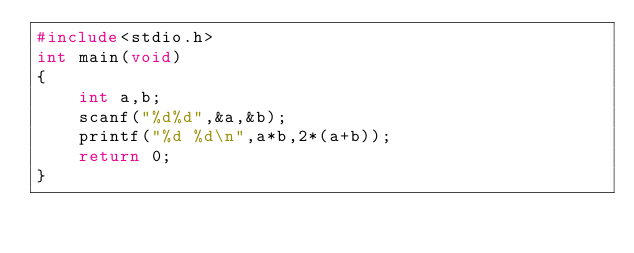Convert code to text. <code><loc_0><loc_0><loc_500><loc_500><_C_>#include<stdio.h>
int main(void)
{
    int a,b;
    scanf("%d%d",&a,&b);
    printf("%d %d\n",a*b,2*(a+b));
    return 0;
}</code> 